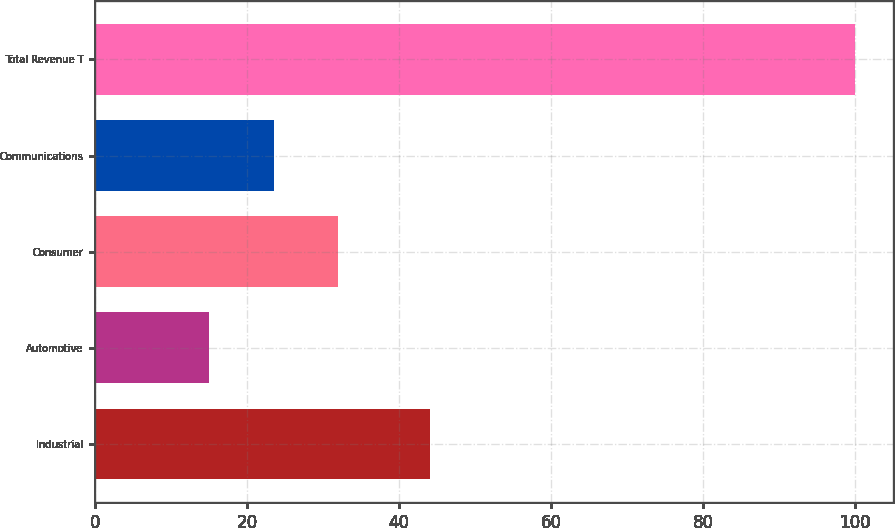<chart> <loc_0><loc_0><loc_500><loc_500><bar_chart><fcel>Industrial<fcel>Automotive<fcel>Consumer<fcel>Communications<fcel>Total Revenue T<nl><fcel>44<fcel>15<fcel>32<fcel>23.5<fcel>100<nl></chart> 